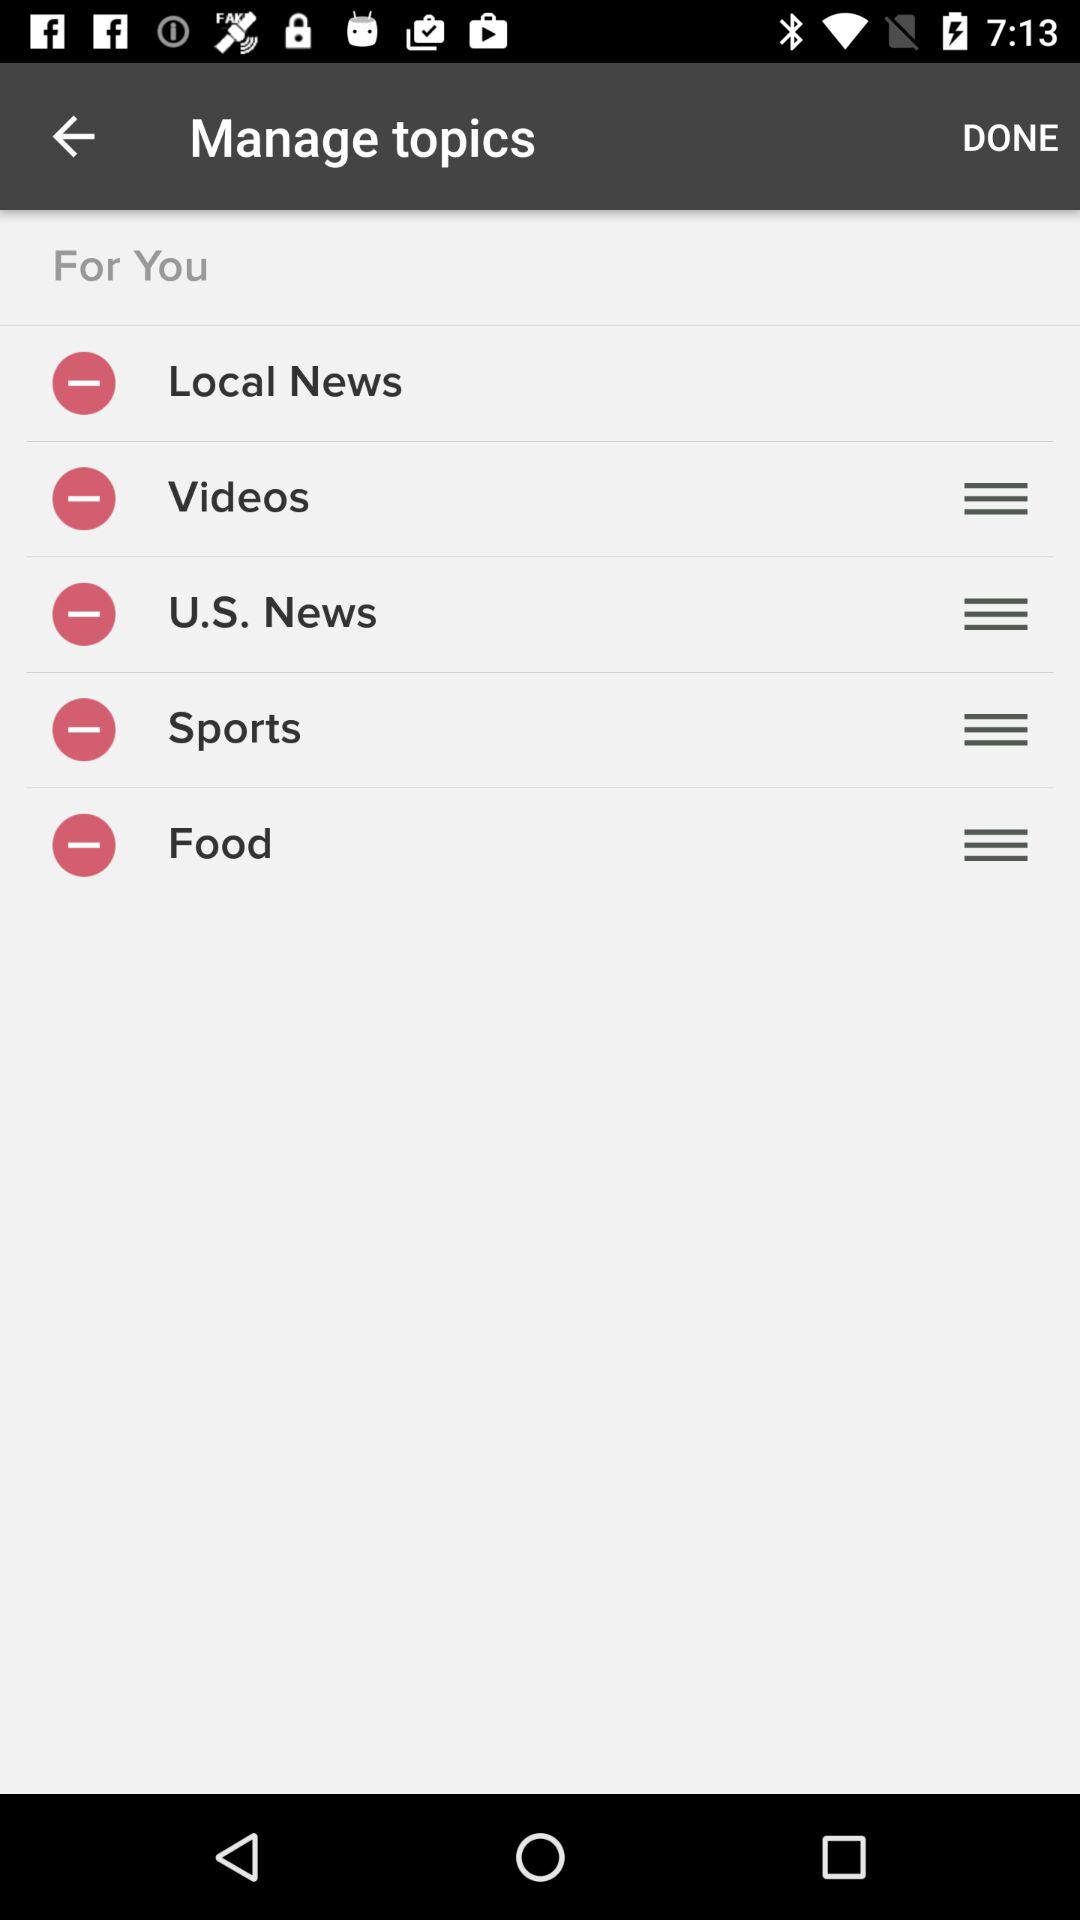How many topics are there?
Answer the question using a single word or phrase. 5 